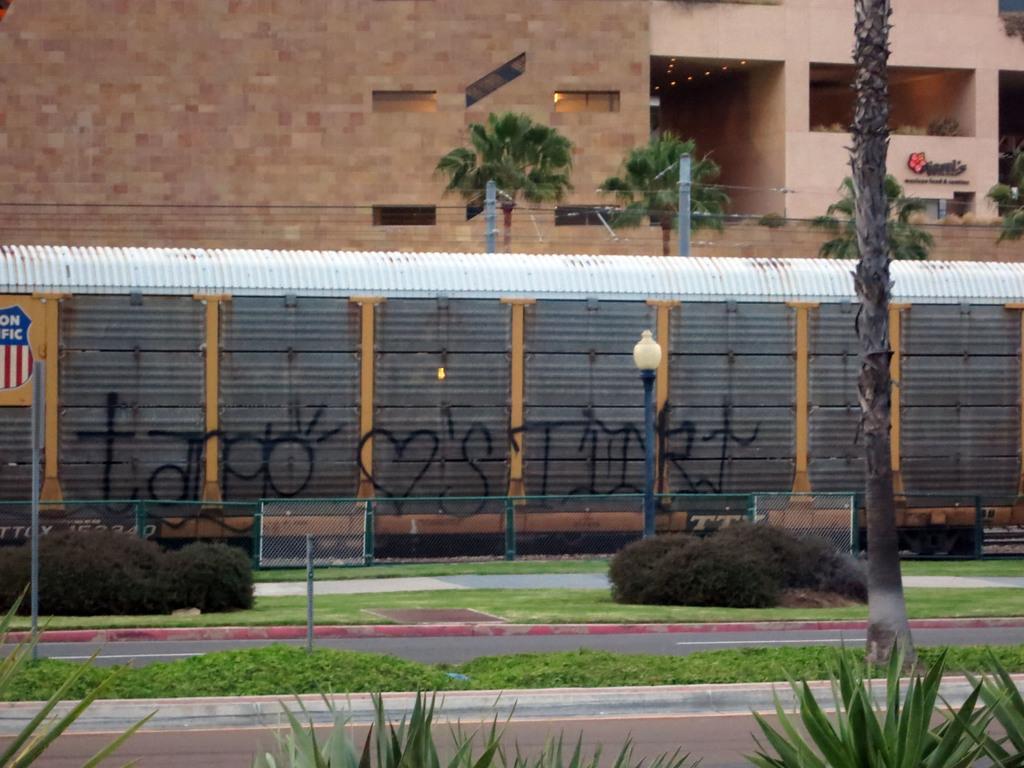Please provide a concise description of this image. In the image there is a train passing on the tracks behind the train there is a huge building and few trees and in the left side there are some bushes and grass and a road. 